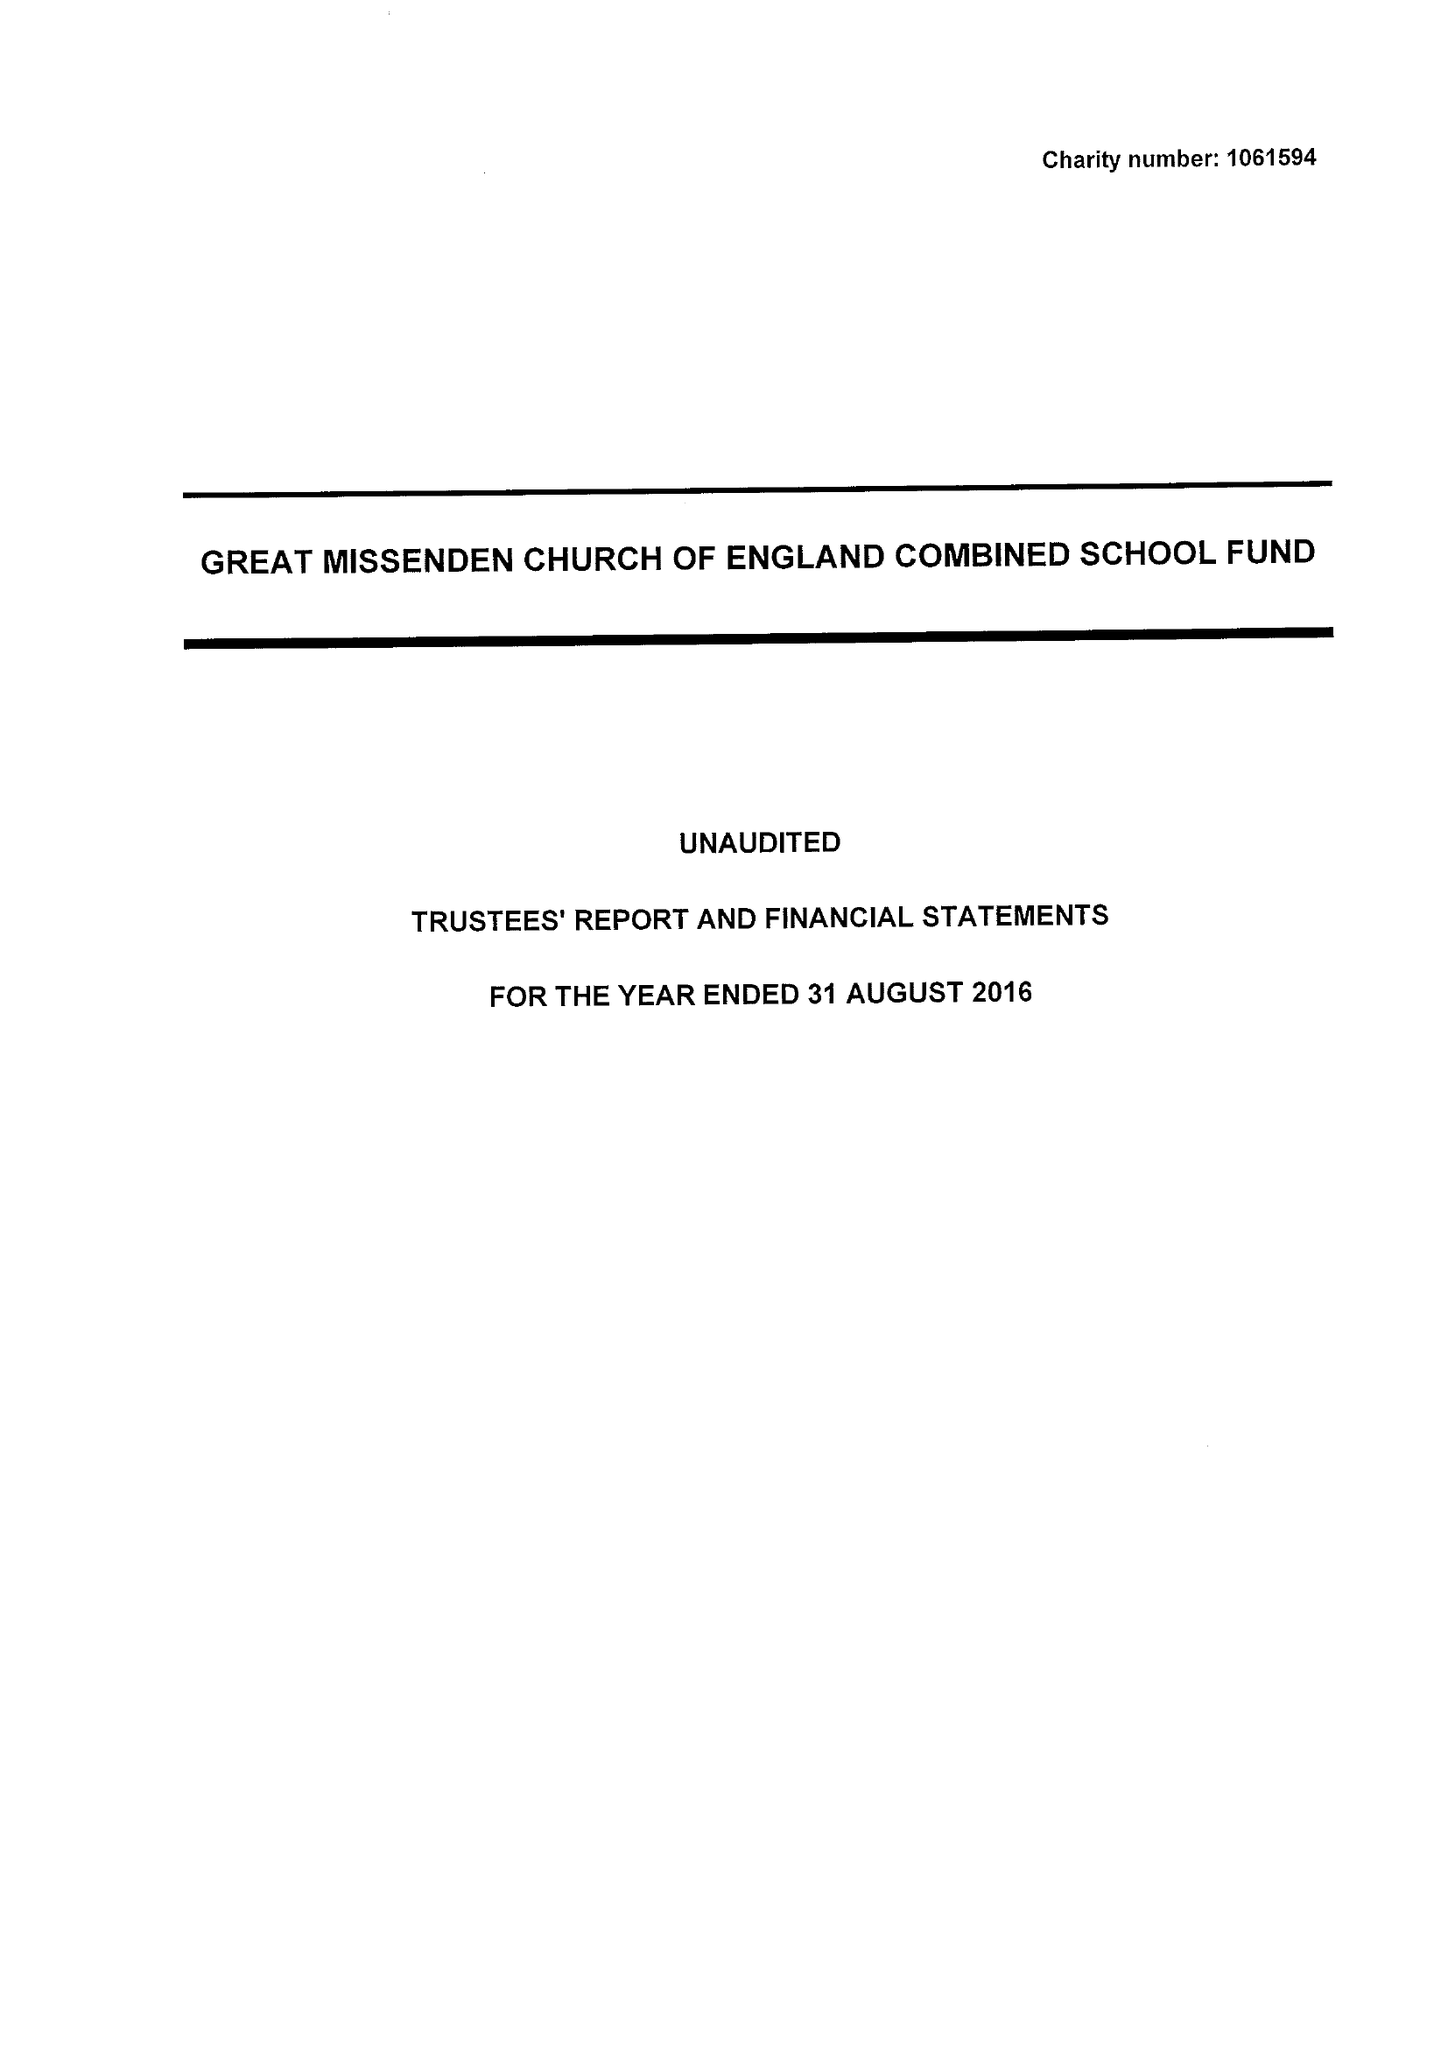What is the value for the address__street_line?
Answer the question using a single word or phrase. CHURCH STREET 